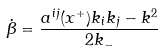<formula> <loc_0><loc_0><loc_500><loc_500>\dot { \beta } = \frac { a ^ { i j } ( x ^ { + } ) k _ { i } k _ { j } - k ^ { 2 } } { 2 k _ { - } }</formula> 